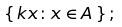Convert formula to latex. <formula><loc_0><loc_0><loc_500><loc_500>\left \{ \, k x \colon x \in A \, \right \} ;</formula> 